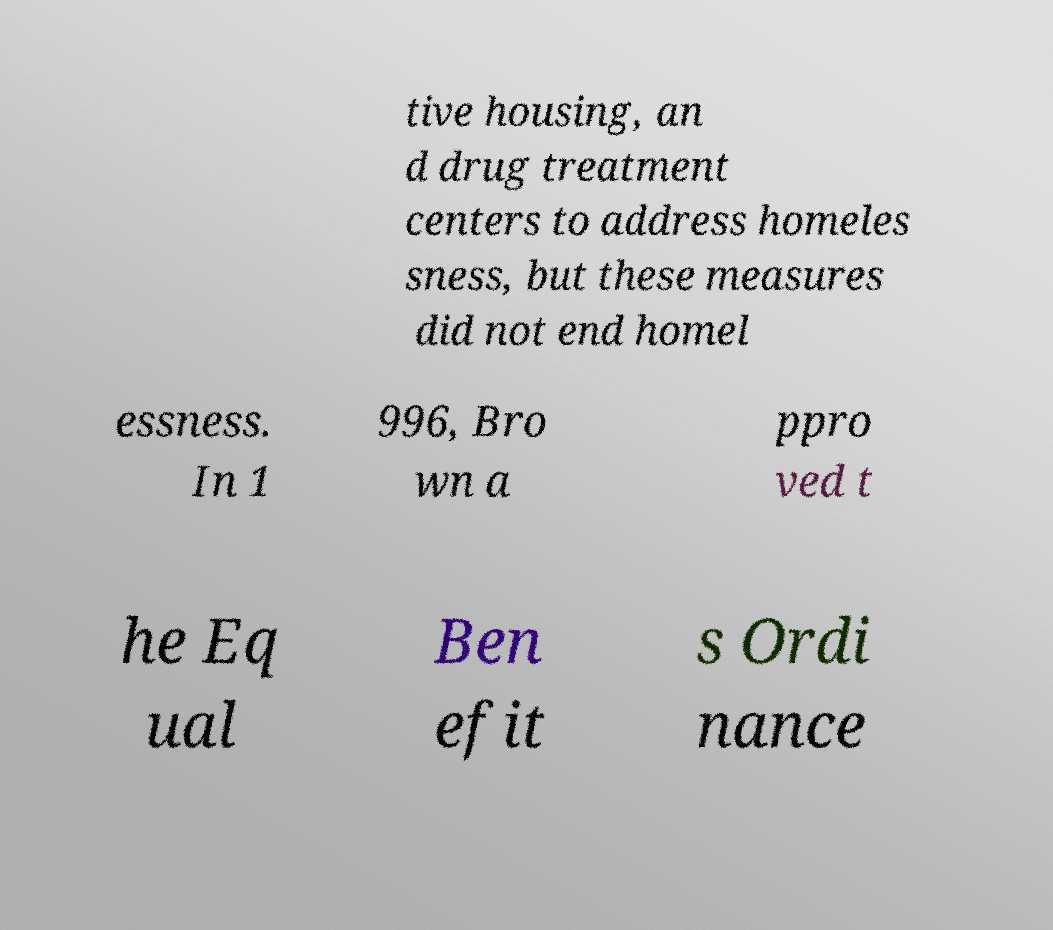What messages or text are displayed in this image? I need them in a readable, typed format. tive housing, an d drug treatment centers to address homeles sness, but these measures did not end homel essness. In 1 996, Bro wn a ppro ved t he Eq ual Ben efit s Ordi nance 